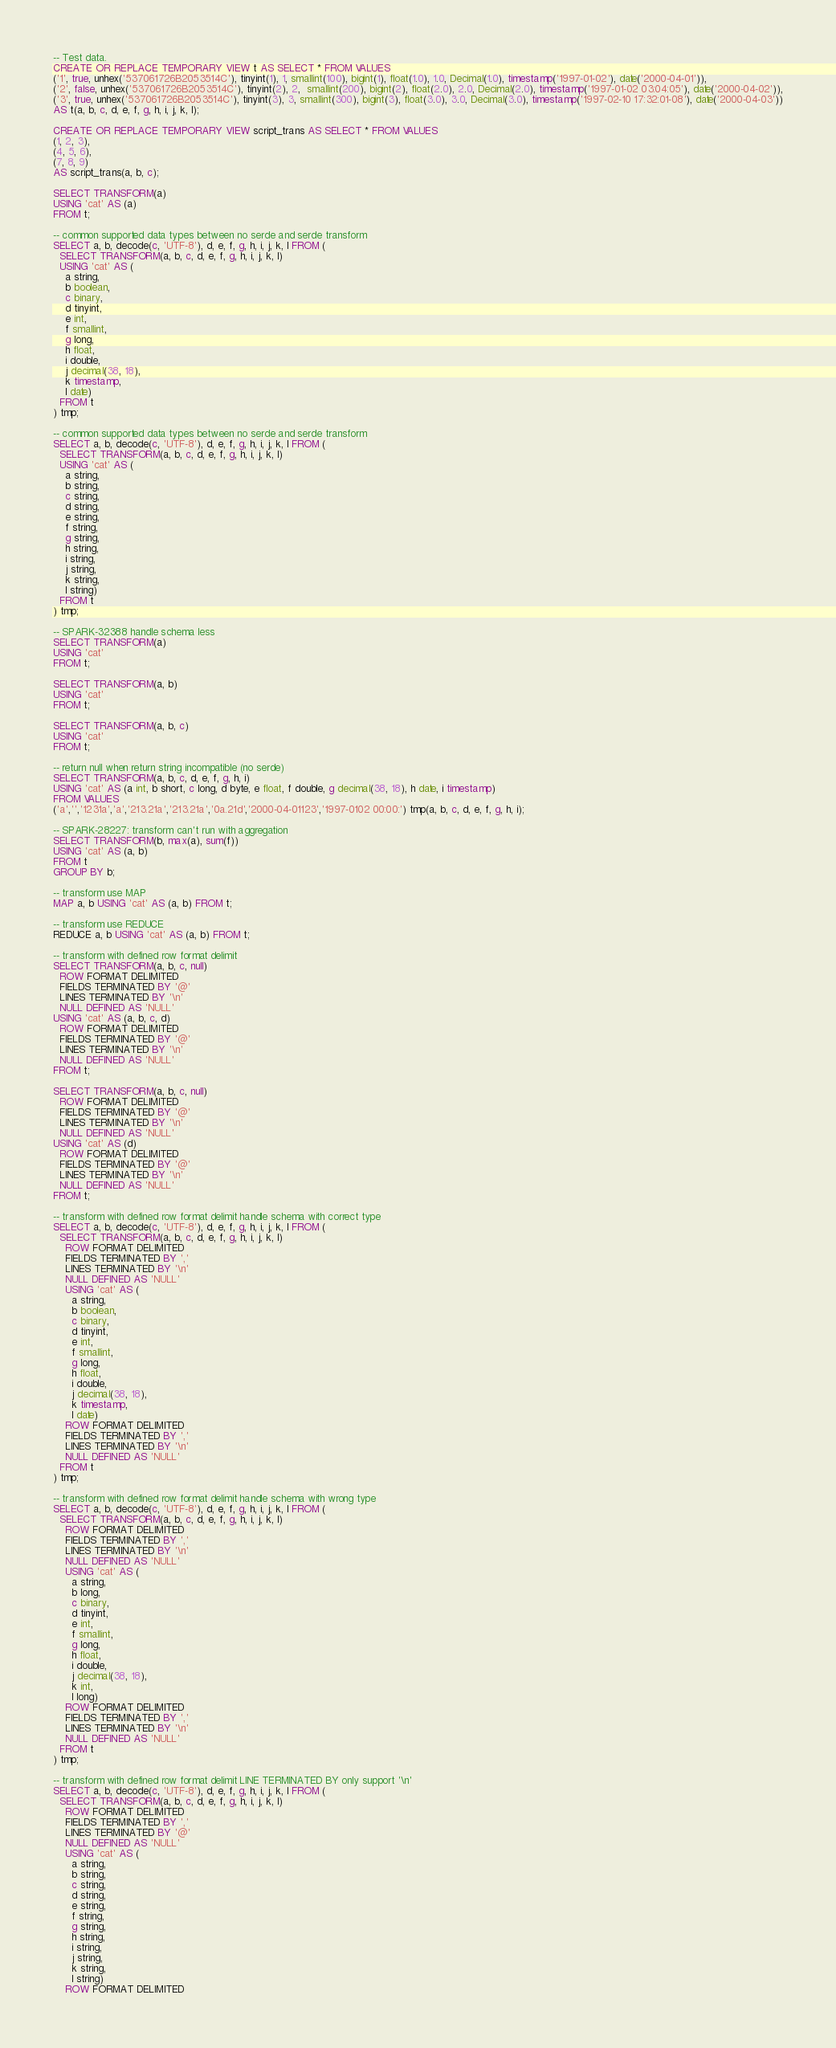Convert code to text. <code><loc_0><loc_0><loc_500><loc_500><_SQL_>-- Test data.
CREATE OR REPLACE TEMPORARY VIEW t AS SELECT * FROM VALUES
('1', true, unhex('537061726B2053514C'), tinyint(1), 1, smallint(100), bigint(1), float(1.0), 1.0, Decimal(1.0), timestamp('1997-01-02'), date('2000-04-01')),
('2', false, unhex('537061726B2053514C'), tinyint(2), 2,  smallint(200), bigint(2), float(2.0), 2.0, Decimal(2.0), timestamp('1997-01-02 03:04:05'), date('2000-04-02')),
('3', true, unhex('537061726B2053514C'), tinyint(3), 3, smallint(300), bigint(3), float(3.0), 3.0, Decimal(3.0), timestamp('1997-02-10 17:32:01-08'), date('2000-04-03'))
AS t(a, b, c, d, e, f, g, h, i, j, k, l);

CREATE OR REPLACE TEMPORARY VIEW script_trans AS SELECT * FROM VALUES
(1, 2, 3),
(4, 5, 6),
(7, 8, 9)
AS script_trans(a, b, c);

SELECT TRANSFORM(a)
USING 'cat' AS (a)
FROM t;

-- common supported data types between no serde and serde transform
SELECT a, b, decode(c, 'UTF-8'), d, e, f, g, h, i, j, k, l FROM (
  SELECT TRANSFORM(a, b, c, d, e, f, g, h, i, j, k, l)
  USING 'cat' AS (
    a string,
    b boolean,
    c binary,
    d tinyint,
    e int,
    f smallint,
    g long,
    h float,
    i double,
    j decimal(38, 18),
    k timestamp,
    l date)
  FROM t
) tmp;

-- common supported data types between no serde and serde transform
SELECT a, b, decode(c, 'UTF-8'), d, e, f, g, h, i, j, k, l FROM (
  SELECT TRANSFORM(a, b, c, d, e, f, g, h, i, j, k, l)
  USING 'cat' AS (
    a string,
    b string,
    c string,
    d string,
    e string,
    f string,
    g string,
    h string,
    i string,
    j string,
    k string,
    l string)
  FROM t
) tmp;

-- SPARK-32388 handle schema less
SELECT TRANSFORM(a)
USING 'cat'
FROM t;

SELECT TRANSFORM(a, b)
USING 'cat'
FROM t;

SELECT TRANSFORM(a, b, c)
USING 'cat'
FROM t;

-- return null when return string incompatible (no serde)
SELECT TRANSFORM(a, b, c, d, e, f, g, h, i)
USING 'cat' AS (a int, b short, c long, d byte, e float, f double, g decimal(38, 18), h date, i timestamp)
FROM VALUES
('a','','1231a','a','213.21a','213.21a','0a.21d','2000-04-01123','1997-0102 00:00:') tmp(a, b, c, d, e, f, g, h, i);

-- SPARK-28227: transform can't run with aggregation
SELECT TRANSFORM(b, max(a), sum(f))
USING 'cat' AS (a, b)
FROM t
GROUP BY b;

-- transform use MAP
MAP a, b USING 'cat' AS (a, b) FROM t;

-- transform use REDUCE
REDUCE a, b USING 'cat' AS (a, b) FROM t;

-- transform with defined row format delimit
SELECT TRANSFORM(a, b, c, null)
  ROW FORMAT DELIMITED
  FIELDS TERMINATED BY '@'
  LINES TERMINATED BY '\n'
  NULL DEFINED AS 'NULL'
USING 'cat' AS (a, b, c, d)
  ROW FORMAT DELIMITED
  FIELDS TERMINATED BY '@'
  LINES TERMINATED BY '\n'
  NULL DEFINED AS 'NULL'
FROM t;

SELECT TRANSFORM(a, b, c, null)
  ROW FORMAT DELIMITED
  FIELDS TERMINATED BY '@'
  LINES TERMINATED BY '\n'
  NULL DEFINED AS 'NULL'
USING 'cat' AS (d)
  ROW FORMAT DELIMITED
  FIELDS TERMINATED BY '@'
  LINES TERMINATED BY '\n'
  NULL DEFINED AS 'NULL'
FROM t;

-- transform with defined row format delimit handle schema with correct type
SELECT a, b, decode(c, 'UTF-8'), d, e, f, g, h, i, j, k, l FROM (
  SELECT TRANSFORM(a, b, c, d, e, f, g, h, i, j, k, l)
    ROW FORMAT DELIMITED
    FIELDS TERMINATED BY ','
    LINES TERMINATED BY '\n'
    NULL DEFINED AS 'NULL'
    USING 'cat' AS (
      a string,
      b boolean,
      c binary,
      d tinyint,
      e int,
      f smallint,
      g long,
      h float,
      i double,
      j decimal(38, 18),
      k timestamp,
      l date)
    ROW FORMAT DELIMITED
    FIELDS TERMINATED BY ','
    LINES TERMINATED BY '\n'
    NULL DEFINED AS 'NULL'
  FROM t
) tmp;

-- transform with defined row format delimit handle schema with wrong type
SELECT a, b, decode(c, 'UTF-8'), d, e, f, g, h, i, j, k, l FROM (
  SELECT TRANSFORM(a, b, c, d, e, f, g, h, i, j, k, l)
    ROW FORMAT DELIMITED
    FIELDS TERMINATED BY ','
    LINES TERMINATED BY '\n'
    NULL DEFINED AS 'NULL'
    USING 'cat' AS (
      a string,
      b long,
      c binary,
      d tinyint,
      e int,
      f smallint,
      g long,
      h float,
      i double,
      j decimal(38, 18),
      k int,
      l long)
    ROW FORMAT DELIMITED
    FIELDS TERMINATED BY ','
    LINES TERMINATED BY '\n'
    NULL DEFINED AS 'NULL'
  FROM t
) tmp;

-- transform with defined row format delimit LINE TERMINATED BY only support '\n'
SELECT a, b, decode(c, 'UTF-8'), d, e, f, g, h, i, j, k, l FROM (
  SELECT TRANSFORM(a, b, c, d, e, f, g, h, i, j, k, l)
    ROW FORMAT DELIMITED
    FIELDS TERMINATED BY ','
    LINES TERMINATED BY '@'
    NULL DEFINED AS 'NULL'
    USING 'cat' AS (
      a string,
      b string,
      c string,
      d string,
      e string,
      f string,
      g string,
      h string,
      i string,
      j string,
      k string,
      l string)
    ROW FORMAT DELIMITED</code> 